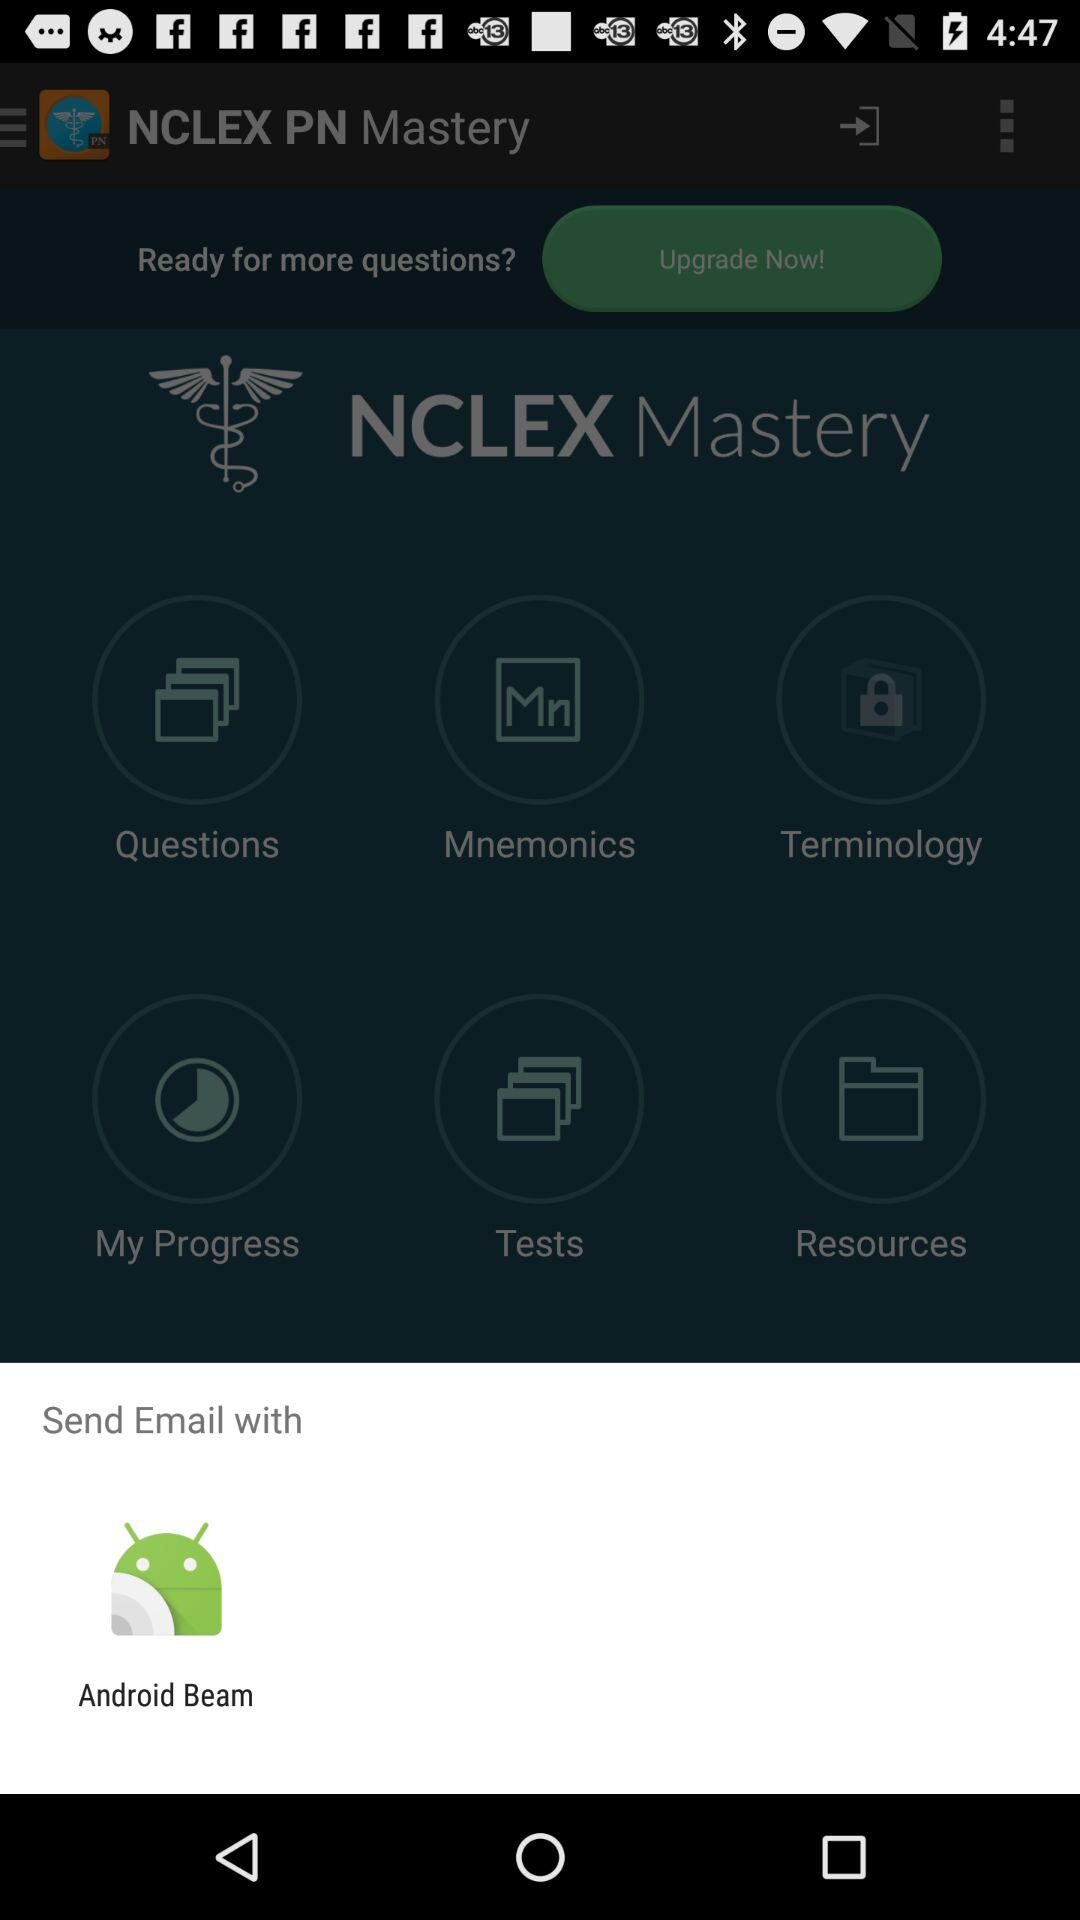What application can the user send email with? The user can send email with "Android Beam". 